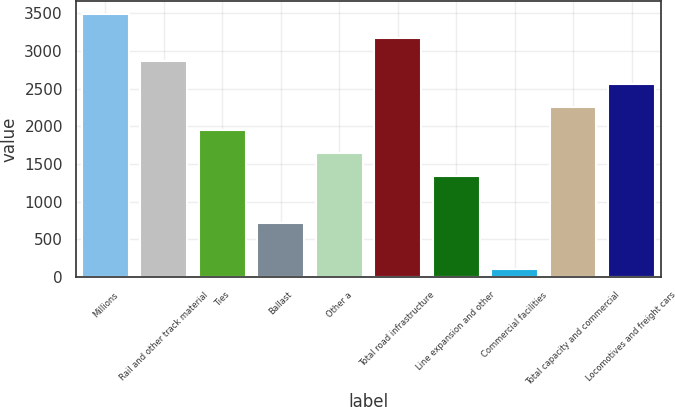Convert chart. <chart><loc_0><loc_0><loc_500><loc_500><bar_chart><fcel>Millions<fcel>Rail and other track material<fcel>Ties<fcel>Ballast<fcel>Other a<fcel>Total road infrastructure<fcel>Line expansion and other<fcel>Commercial facilities<fcel>Total capacity and commercial<fcel>Locomotives and freight cars<nl><fcel>3482.5<fcel>2869.5<fcel>1950<fcel>724<fcel>1643.5<fcel>3176<fcel>1337<fcel>111<fcel>2256.5<fcel>2563<nl></chart> 